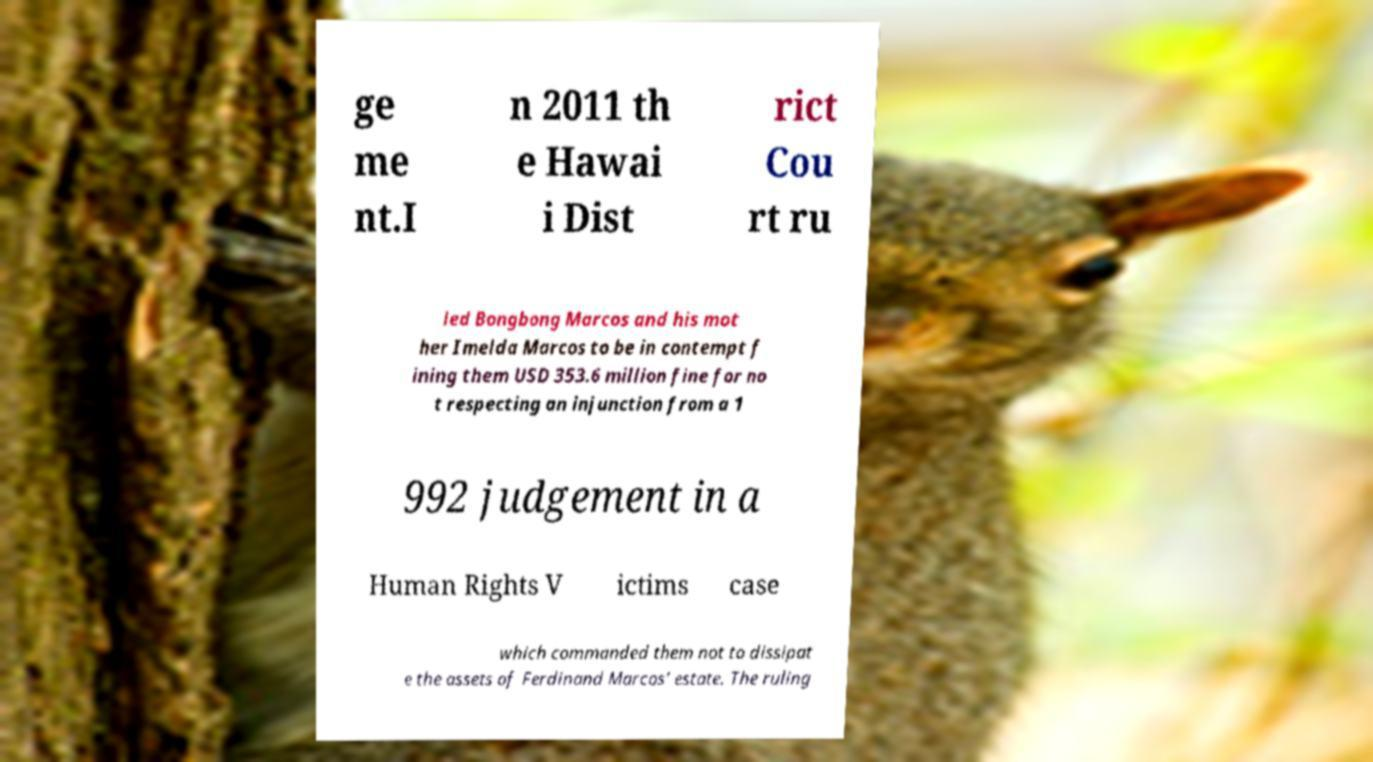What messages or text are displayed in this image? I need them in a readable, typed format. ge me nt.I n 2011 th e Hawai i Dist rict Cou rt ru led Bongbong Marcos and his mot her Imelda Marcos to be in contempt f ining them USD 353.6 million fine for no t respecting an injunction from a 1 992 judgement in a Human Rights V ictims case which commanded them not to dissipat e the assets of Ferdinand Marcos’ estate. The ruling 